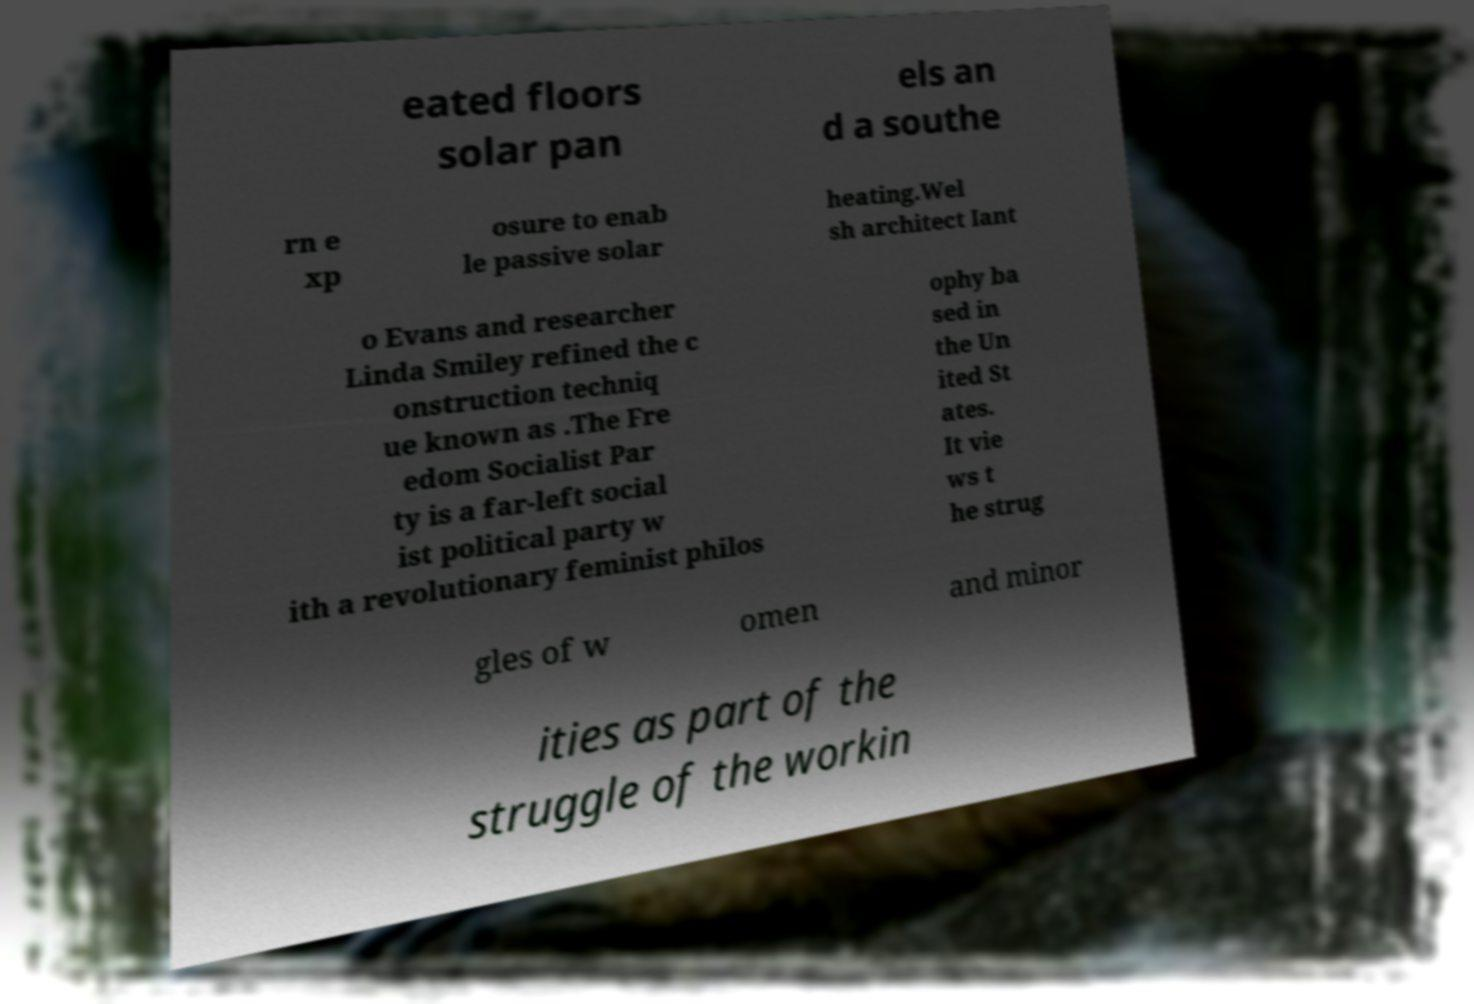Please read and relay the text visible in this image. What does it say? eated floors solar pan els an d a southe rn e xp osure to enab le passive solar heating.Wel sh architect Iant o Evans and researcher Linda Smiley refined the c onstruction techniq ue known as .The Fre edom Socialist Par ty is a far-left social ist political party w ith a revolutionary feminist philos ophy ba sed in the Un ited St ates. It vie ws t he strug gles of w omen and minor ities as part of the struggle of the workin 